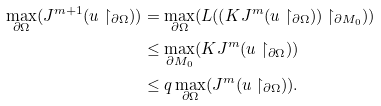<formula> <loc_0><loc_0><loc_500><loc_500>\max _ { \partial \Omega } ( J ^ { m + 1 } ( u \restriction _ { \partial \Omega } ) ) & = \max _ { \partial \Omega } ( L ( ( K J ^ { m } ( u \restriction _ { \partial \Omega } ) ) \restriction _ { \partial M _ { 0 } } ) ) \\ & \leq \max _ { \partial M _ { 0 } } ( K J ^ { m } ( u \restriction _ { \partial \Omega } ) ) \\ & \leq q \max _ { \partial \Omega } ( J ^ { m } ( u \restriction _ { \partial \Omega } ) ) .</formula> 